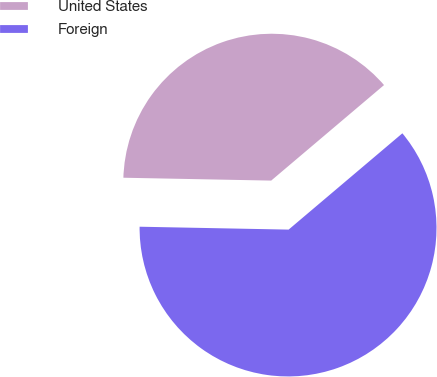Convert chart. <chart><loc_0><loc_0><loc_500><loc_500><pie_chart><fcel>United States<fcel>Foreign<nl><fcel>38.51%<fcel>61.49%<nl></chart> 